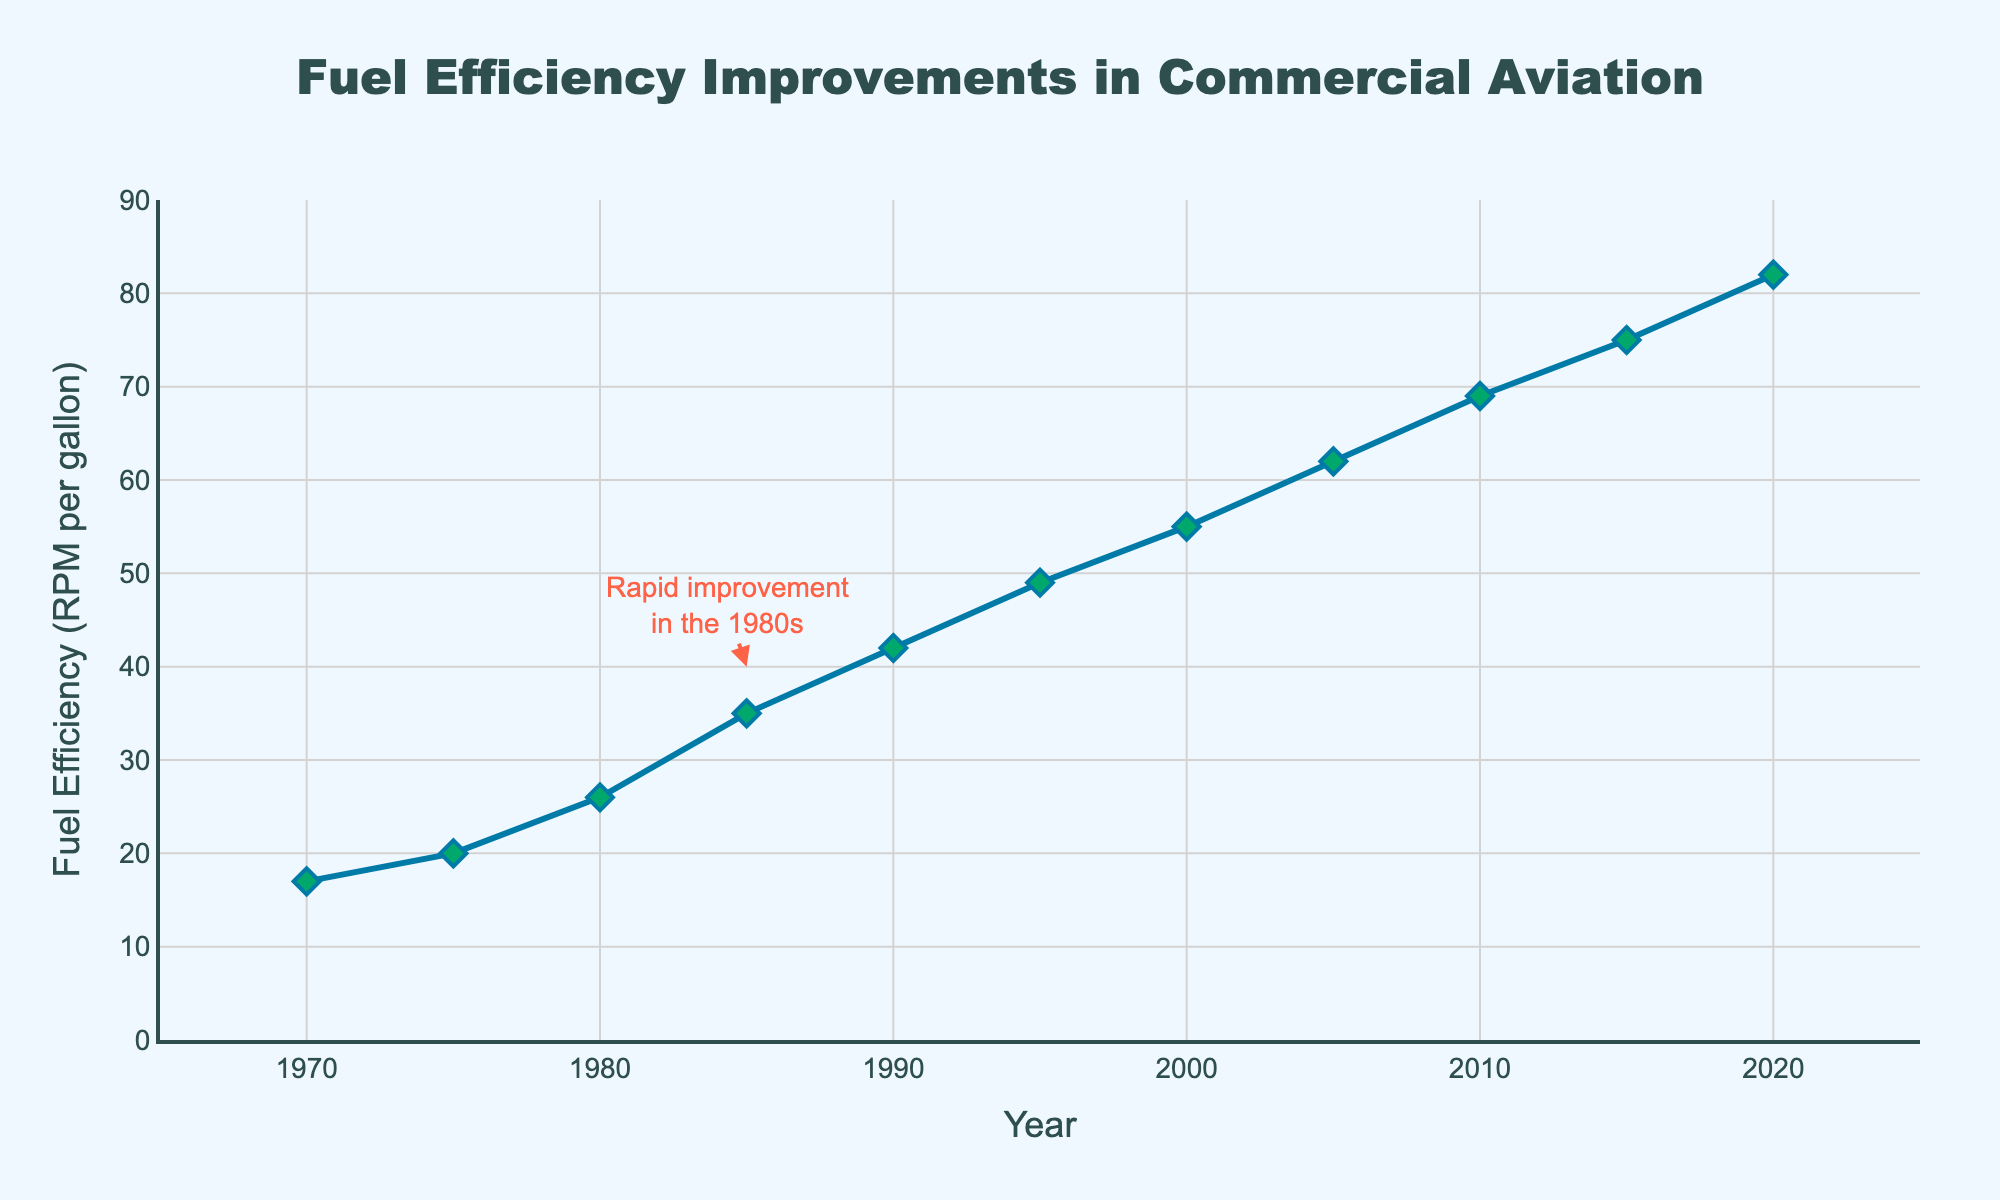What year shows the most significant improvement in fuel efficiency according to the chart annotation? The annotation on the chart points to the year 1985 and mentions a rapid improvement in fuel efficiency in the 1980s.
Answer: 1985 How much did fuel efficiency improve from 1980 to 1985? Referring to the chart, the fuel efficiency in 1980 was 26 RPM per gallon, and in 1985 it was 35 RPM per gallon. The improvement equals 35 - 26.
Answer: 9 RPM per gallon In which decade does the chart indicate the highest rate of change in fuel efficiency? By analyzing the slope of the graph over different decades, the 1980s show the steepest upward trend, indicating the highest rate of improvement in fuel efficiency.
Answer: 1980s What is the fuel efficiency in the year 2000, and how much has it increased from 1970? According to the chart, the fuel efficiency in 2000 is 55 RPM per gallon. To find the increase, subtract the efficiency in 1970, which is 17 RPM per gallon, from the efficiency in 2000. 55 - 17 = 38.
Answer: 38 RPM per gallon Is the data trend generally upward or downward over the 50 years shown? The plotted line in the chart moves consistently upward from 1970 to 2020, showing a general increase in fuel efficiency.
Answer: Upward Which year marks the first time fuel efficiency exceeds 60 RPM per gallon? By examining the data points on the chart, we see that the fuel efficiency first surpasses 60 RPM per gallon in 2005.
Answer: 2005 Compare the fuel efficiencies of the years 1975 and 1995. Which year was more fuel-efficient? Referring to the chart, the fuel efficiency in 1975 is 20 RPM per gallon, while in 1995 it is 49 RPM per gallon. 1995 is more fuel-efficient.
Answer: 1995 What is the average fuel efficiency from the first five data points (1970 to 1990)? Add the fuel efficiency values for the years 1970, 1975, 1980, 1985, and 1990: 17 + 20 + 26 + 35 + 42 = 140. Divide by the number of data points: 140 / 5.
Answer: 28 RPM per gallon By how many RPM per gallon did fuel efficiency improve from 1990 to 2020? Check the chart for the fuel efficiency values in 1990 (42 RPM per gallon) and 2020 (82 RPM per gallon), then calculate the difference: 82 - 42 = 40.
Answer: 40 RPM per gallon 